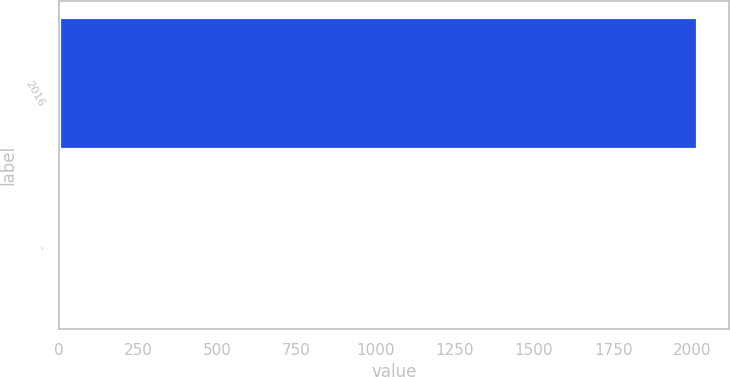Convert chart. <chart><loc_0><loc_0><loc_500><loc_500><bar_chart><fcel>2016<fcel>-<nl><fcel>2016<fcel>0.1<nl></chart> 